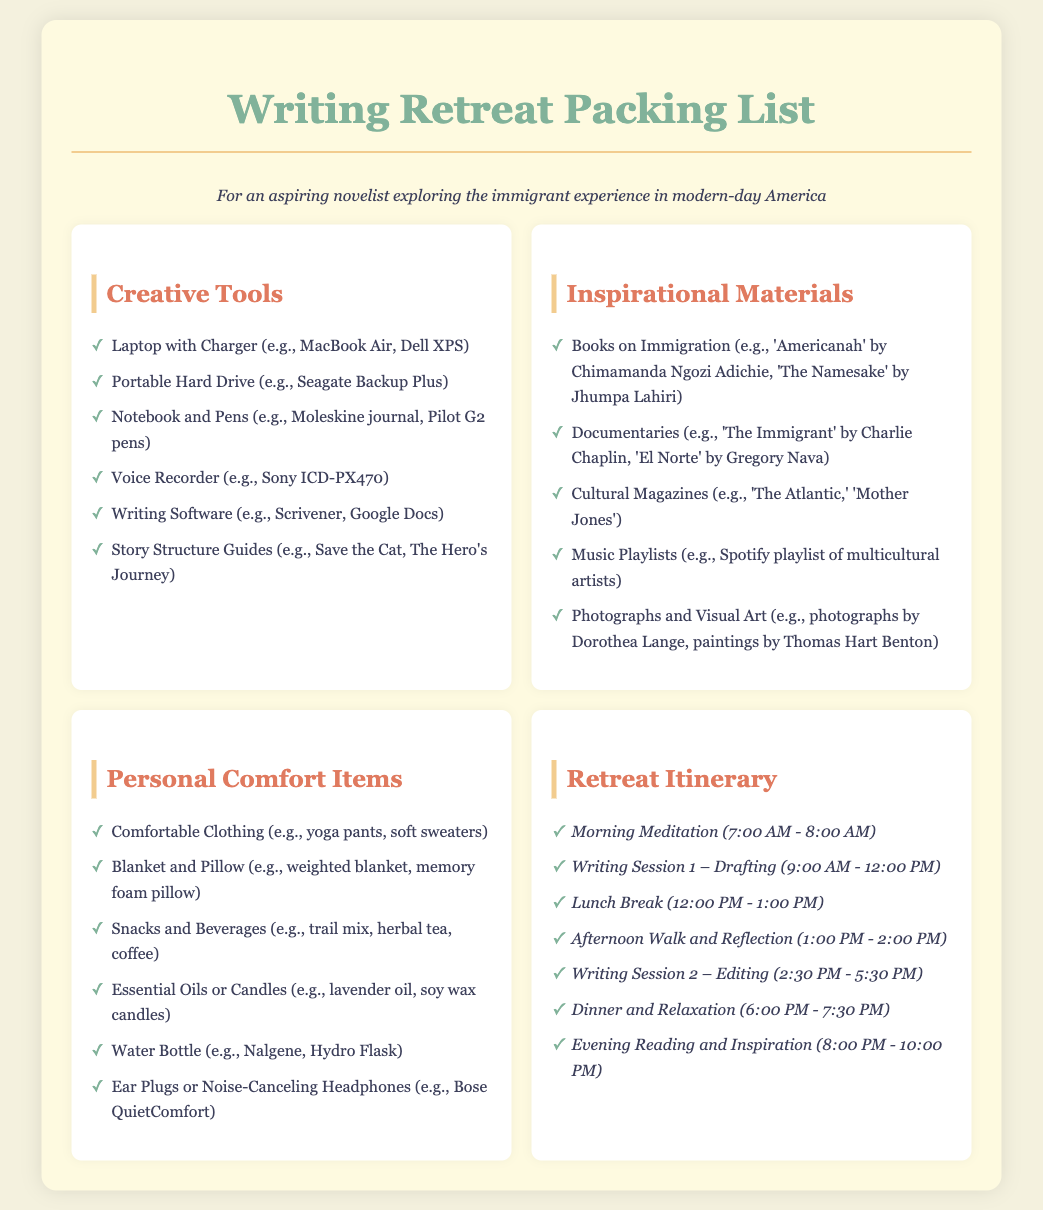What is the first item listed in the Creative Tools section? The first item listed in the Creative Tools section is "Laptop with Charger."
Answer: Laptop with Charger How many writing sessions are scheduled in the itinerary? The itinerary includes two writing sessions: one for drafting and one for editing.
Answer: 2 What is one of the inspirational materials suggested for the retreat? An example of an inspirational material is "Books on Immigration."
Answer: Books on Immigration What is the duration of the Morning Meditation? The duration of the Morning Meditation is one hour, from 7:00 AM to 8:00 AM.
Answer: 1 hour Which item in the Personal Comfort Items section is mentioned as a type of clothing? The item mentioned is "Comfortable Clothing."
Answer: Comfortable Clothing What time does the Evening Reading and Inspiration start? The Evening Reading and Inspiration starts at 8:00 PM.
Answer: 8:00 PM What type of oil is suggested under Personal Comfort Items? Lavender oil is suggested under Personal Comfort Items.
Answer: Lavender oil What is the purpose of the Afternoon Walk and Reflection? The purpose is for reflection during the retreat.
Answer: Reflection How is the aesthetic layout of the document described in terms of background color? The background color is described as a light, neutral shade (#f4f1de).
Answer: Light neutral shade 